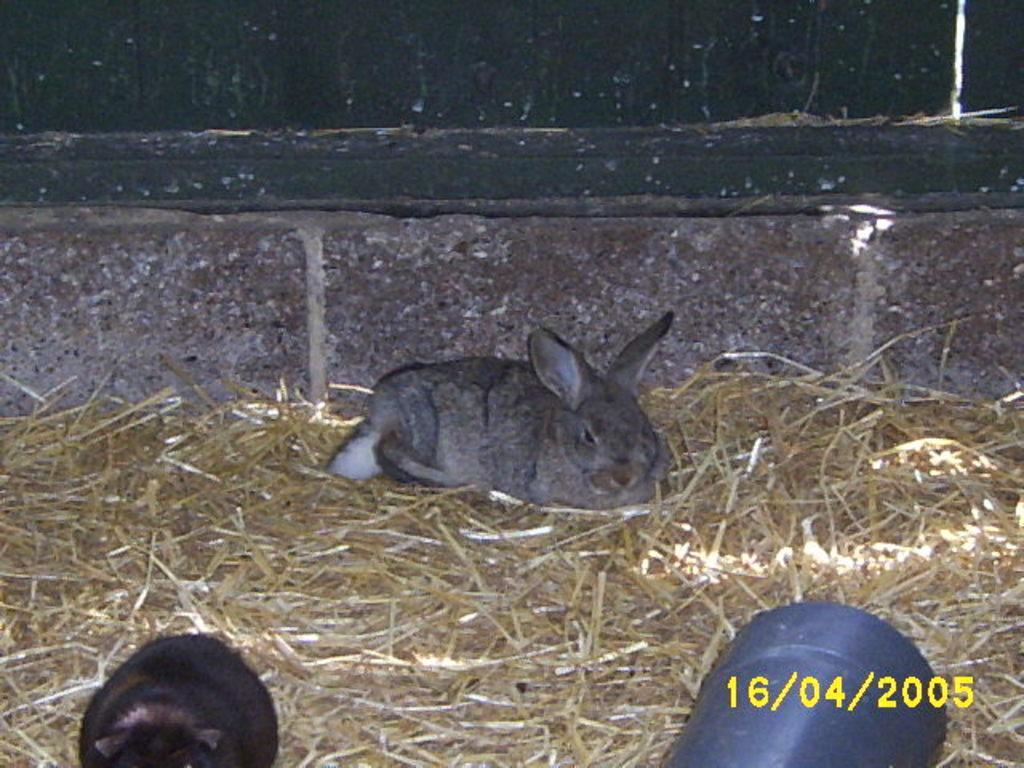How would you summarize this image in a sentence or two? In this image in the center there is a rabbit, and at the bottom there is dry grass and there is another rabbit and some pipe and there is text. And in the background there might be a wall. 